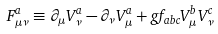Convert formula to latex. <formula><loc_0><loc_0><loc_500><loc_500>F _ { \mu \nu } ^ { a } \equiv \partial _ { \mu } V _ { \nu } ^ { a } - \partial _ { \nu } V _ { \mu } ^ { a } + g f _ { a b c } V _ { \mu } ^ { b } V _ { \nu } ^ { c }</formula> 